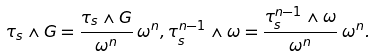<formula> <loc_0><loc_0><loc_500><loc_500>\tau _ { s } \wedge G = \frac { \tau _ { s } \wedge G } { \omega ^ { n } } \, \omega ^ { n } , \tau _ { s } ^ { n - 1 } \wedge \omega = \frac { \tau _ { s } ^ { n - 1 } \wedge \omega } { \omega ^ { n } } \, \omega ^ { n } .</formula> 